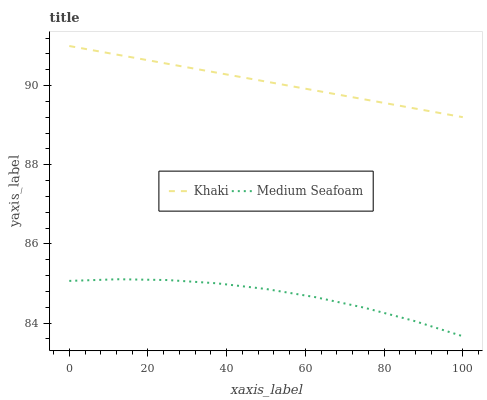Does Medium Seafoam have the minimum area under the curve?
Answer yes or no. Yes. Does Khaki have the maximum area under the curve?
Answer yes or no. Yes. Does Medium Seafoam have the maximum area under the curve?
Answer yes or no. No. Is Khaki the smoothest?
Answer yes or no. Yes. Is Medium Seafoam the roughest?
Answer yes or no. Yes. Is Medium Seafoam the smoothest?
Answer yes or no. No. Does Medium Seafoam have the lowest value?
Answer yes or no. Yes. Does Khaki have the highest value?
Answer yes or no. Yes. Does Medium Seafoam have the highest value?
Answer yes or no. No. Is Medium Seafoam less than Khaki?
Answer yes or no. Yes. Is Khaki greater than Medium Seafoam?
Answer yes or no. Yes. Does Medium Seafoam intersect Khaki?
Answer yes or no. No. 